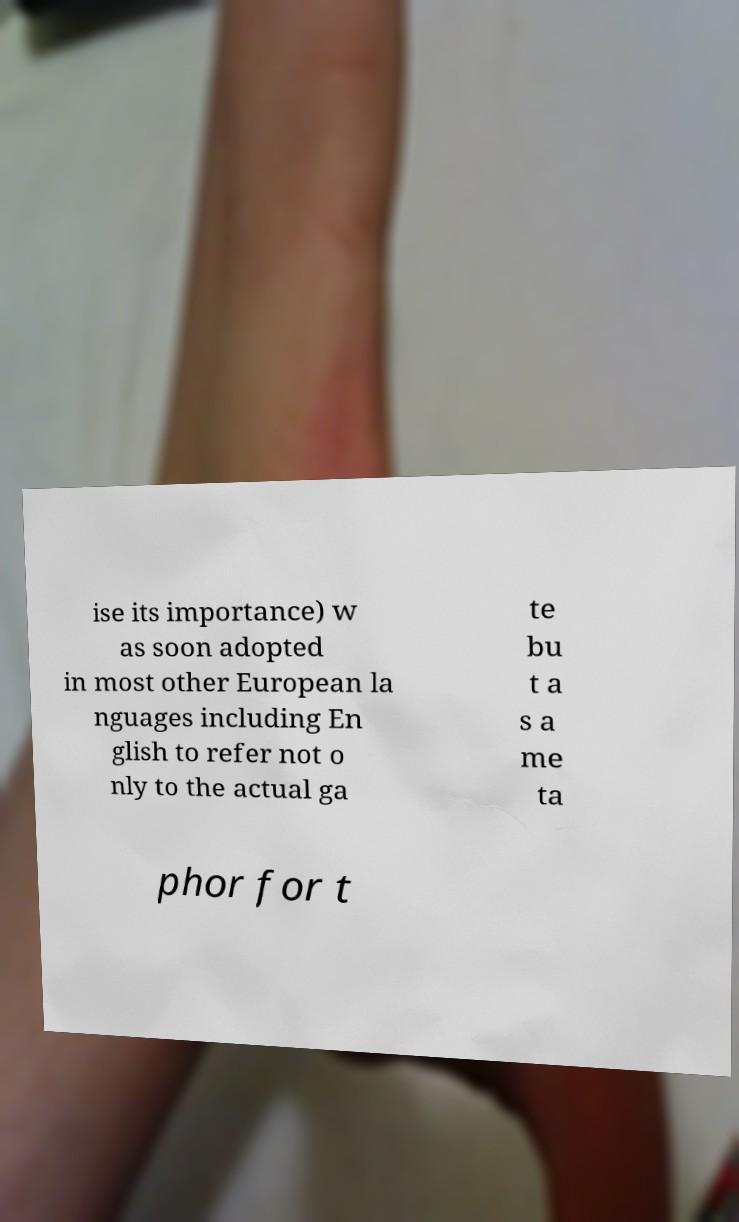For documentation purposes, I need the text within this image transcribed. Could you provide that? ise its importance) w as soon adopted in most other European la nguages including En glish to refer not o nly to the actual ga te bu t a s a me ta phor for t 